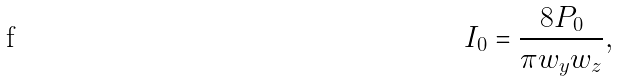<formula> <loc_0><loc_0><loc_500><loc_500>I _ { 0 } = \frac { 8 P _ { 0 } } { \pi w _ { y } w _ { z } } ,</formula> 